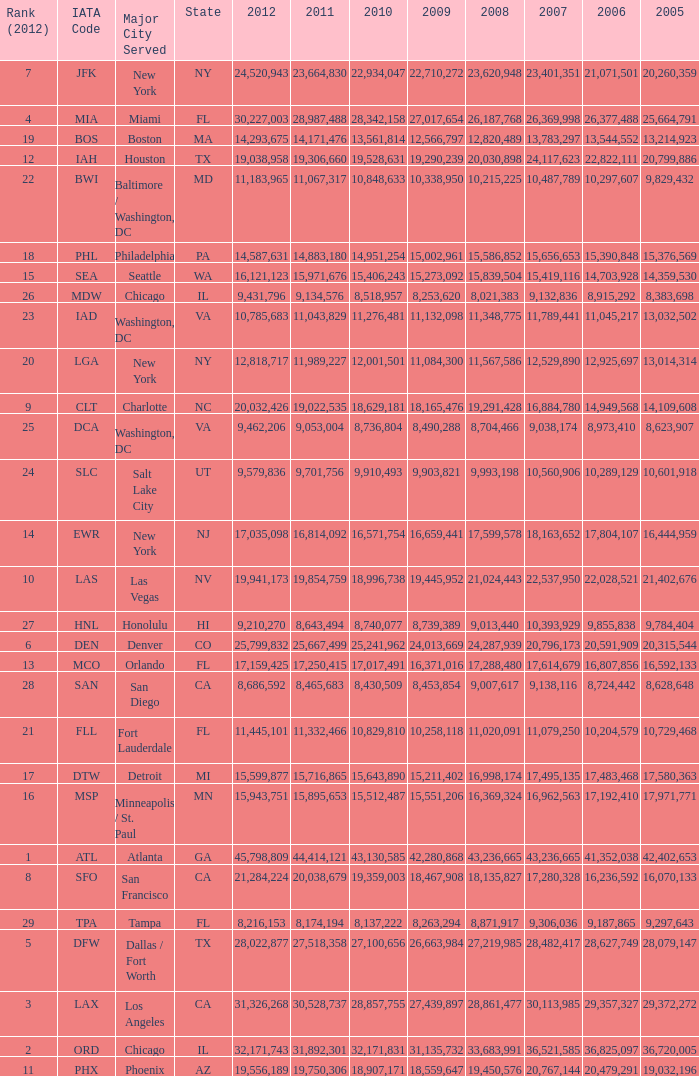What is the greatest 2010 for Miami, Fl? 28342158.0. 